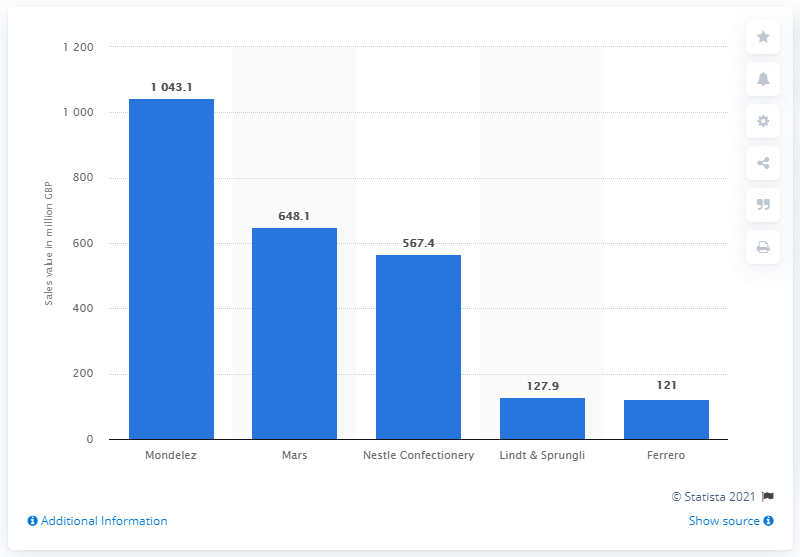Indicate a few pertinent items in this graphic. Mars is the second largest confectionery manufacturer in the United Kingdom. Mondelez's revenue in 2016 was 1043.1 million. 